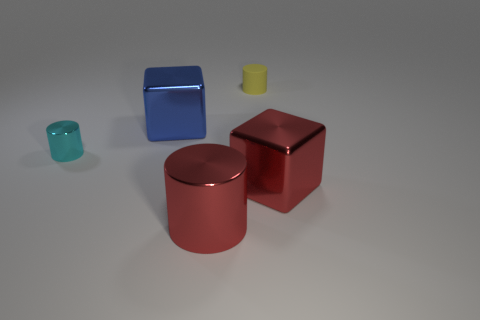Subtract all shiny cylinders. How many cylinders are left? 1 Subtract 1 cylinders. How many cylinders are left? 2 Add 4 small objects. How many objects exist? 9 Subtract all brown cylinders. Subtract all green spheres. How many cylinders are left? 3 Add 5 cyan metal cylinders. How many cyan metal cylinders exist? 6 Subtract 1 red cylinders. How many objects are left? 4 Subtract all cylinders. How many objects are left? 2 Subtract all small cyan shiny cylinders. Subtract all red matte balls. How many objects are left? 4 Add 1 tiny yellow matte things. How many tiny yellow matte things are left? 2 